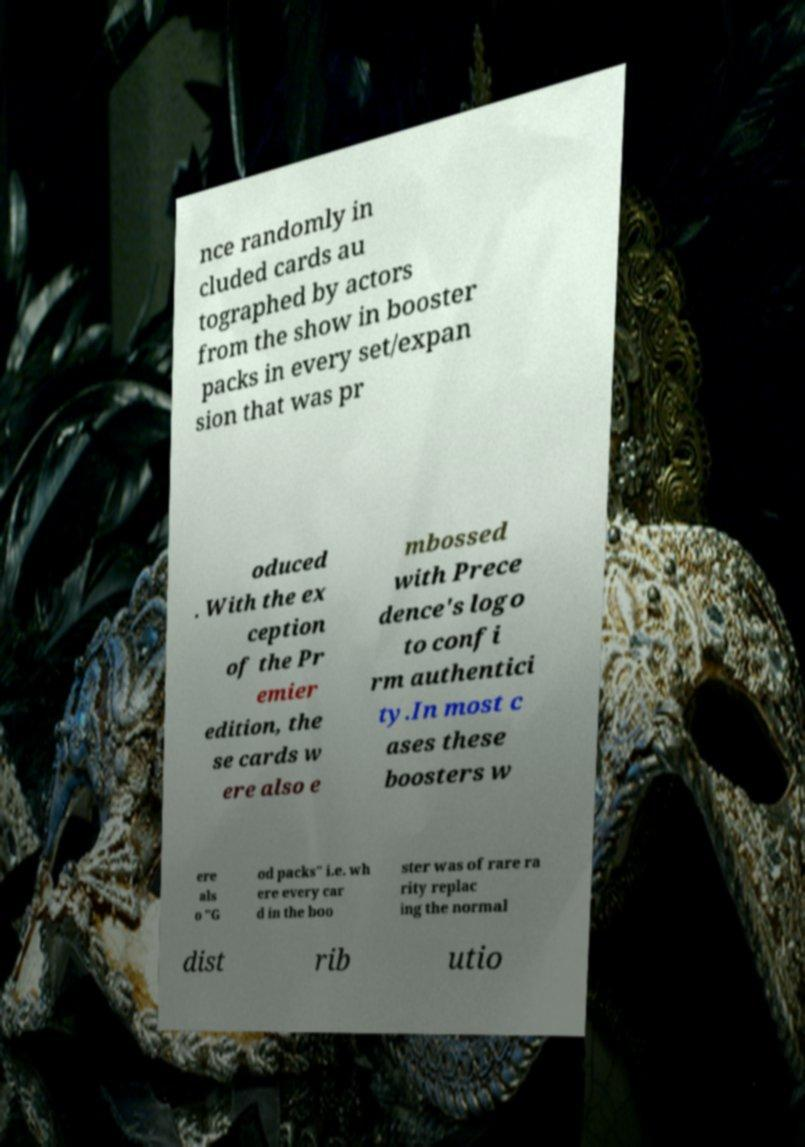For documentation purposes, I need the text within this image transcribed. Could you provide that? nce randomly in cluded cards au tographed by actors from the show in booster packs in every set/expan sion that was pr oduced . With the ex ception of the Pr emier edition, the se cards w ere also e mbossed with Prece dence's logo to confi rm authentici ty.In most c ases these boosters w ere als o "G od packs" i.e. wh ere every car d in the boo ster was of rare ra rity replac ing the normal dist rib utio 